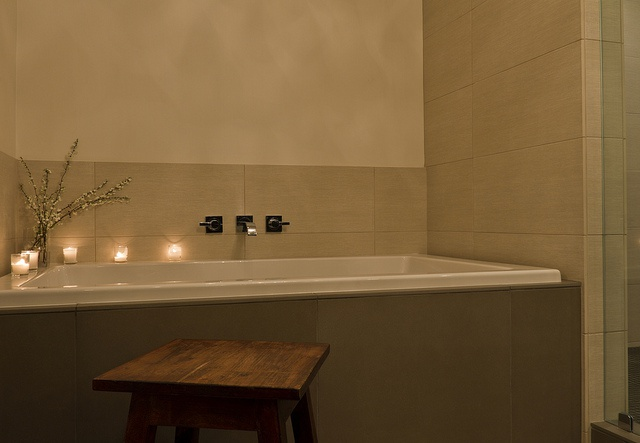Describe the objects in this image and their specific colors. I can see vase in olive, maroon, and black tones, cup in olive, tan, and ivory tones, cup in olive, gray, and tan tones, and cup in olive and tan tones in this image. 